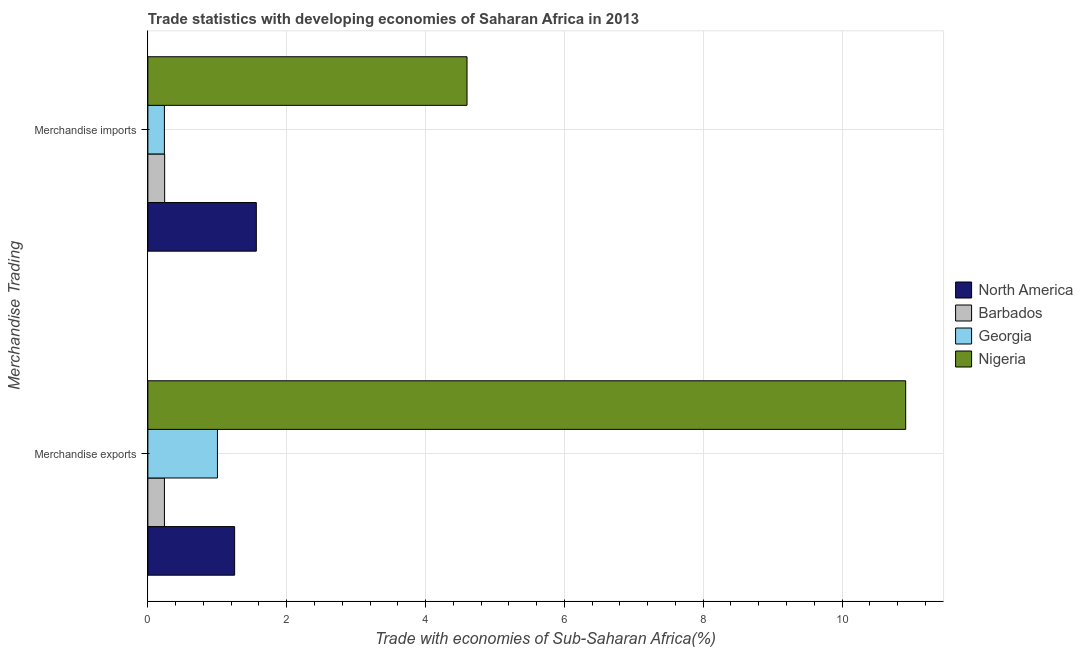How many groups of bars are there?
Provide a short and direct response. 2. How many bars are there on the 1st tick from the bottom?
Offer a very short reply. 4. What is the label of the 1st group of bars from the top?
Your answer should be very brief. Merchandise imports. What is the merchandise imports in North America?
Keep it short and to the point. 1.56. Across all countries, what is the maximum merchandise imports?
Offer a terse response. 4.6. Across all countries, what is the minimum merchandise imports?
Offer a terse response. 0.24. In which country was the merchandise imports maximum?
Your answer should be very brief. Nigeria. In which country was the merchandise imports minimum?
Your answer should be compact. Georgia. What is the total merchandise imports in the graph?
Your response must be concise. 6.64. What is the difference between the merchandise exports in Georgia and that in Barbados?
Your response must be concise. 0.76. What is the difference between the merchandise exports in Georgia and the merchandise imports in Nigeria?
Provide a short and direct response. -3.6. What is the average merchandise imports per country?
Offer a terse response. 1.66. What is the difference between the merchandise imports and merchandise exports in Nigeria?
Your response must be concise. -6.32. In how many countries, is the merchandise imports greater than 10 %?
Make the answer very short. 0. What is the ratio of the merchandise imports in Nigeria to that in Barbados?
Offer a very short reply. 19.02. Is the merchandise imports in North America less than that in Barbados?
Your response must be concise. No. In how many countries, is the merchandise imports greater than the average merchandise imports taken over all countries?
Your answer should be very brief. 1. What does the 3rd bar from the top in Merchandise imports represents?
Your answer should be compact. Barbados. What does the 2nd bar from the bottom in Merchandise imports represents?
Make the answer very short. Barbados. How many bars are there?
Your answer should be very brief. 8. Are all the bars in the graph horizontal?
Ensure brevity in your answer.  Yes. What is the difference between two consecutive major ticks on the X-axis?
Offer a terse response. 2. Are the values on the major ticks of X-axis written in scientific E-notation?
Ensure brevity in your answer.  No. Does the graph contain any zero values?
Keep it short and to the point. No. Where does the legend appear in the graph?
Offer a terse response. Center right. How are the legend labels stacked?
Offer a terse response. Vertical. What is the title of the graph?
Your answer should be very brief. Trade statistics with developing economies of Saharan Africa in 2013. What is the label or title of the X-axis?
Offer a very short reply. Trade with economies of Sub-Saharan Africa(%). What is the label or title of the Y-axis?
Keep it short and to the point. Merchandise Trading. What is the Trade with economies of Sub-Saharan Africa(%) in North America in Merchandise exports?
Give a very brief answer. 1.25. What is the Trade with economies of Sub-Saharan Africa(%) in Barbados in Merchandise exports?
Make the answer very short. 0.24. What is the Trade with economies of Sub-Saharan Africa(%) of Georgia in Merchandise exports?
Your response must be concise. 1. What is the Trade with economies of Sub-Saharan Africa(%) of Nigeria in Merchandise exports?
Offer a very short reply. 10.92. What is the Trade with economies of Sub-Saharan Africa(%) of North America in Merchandise imports?
Provide a succinct answer. 1.56. What is the Trade with economies of Sub-Saharan Africa(%) of Barbados in Merchandise imports?
Your answer should be very brief. 0.24. What is the Trade with economies of Sub-Saharan Africa(%) in Georgia in Merchandise imports?
Your answer should be very brief. 0.24. What is the Trade with economies of Sub-Saharan Africa(%) in Nigeria in Merchandise imports?
Your answer should be very brief. 4.6. Across all Merchandise Trading, what is the maximum Trade with economies of Sub-Saharan Africa(%) in North America?
Your response must be concise. 1.56. Across all Merchandise Trading, what is the maximum Trade with economies of Sub-Saharan Africa(%) in Barbados?
Your answer should be compact. 0.24. Across all Merchandise Trading, what is the maximum Trade with economies of Sub-Saharan Africa(%) in Georgia?
Give a very brief answer. 1. Across all Merchandise Trading, what is the maximum Trade with economies of Sub-Saharan Africa(%) in Nigeria?
Make the answer very short. 10.92. Across all Merchandise Trading, what is the minimum Trade with economies of Sub-Saharan Africa(%) in North America?
Your answer should be compact. 1.25. Across all Merchandise Trading, what is the minimum Trade with economies of Sub-Saharan Africa(%) in Barbados?
Provide a succinct answer. 0.24. Across all Merchandise Trading, what is the minimum Trade with economies of Sub-Saharan Africa(%) of Georgia?
Provide a short and direct response. 0.24. Across all Merchandise Trading, what is the minimum Trade with economies of Sub-Saharan Africa(%) of Nigeria?
Give a very brief answer. 4.6. What is the total Trade with economies of Sub-Saharan Africa(%) in North America in the graph?
Offer a terse response. 2.81. What is the total Trade with economies of Sub-Saharan Africa(%) in Barbados in the graph?
Make the answer very short. 0.48. What is the total Trade with economies of Sub-Saharan Africa(%) in Georgia in the graph?
Offer a terse response. 1.24. What is the total Trade with economies of Sub-Saharan Africa(%) in Nigeria in the graph?
Your response must be concise. 15.51. What is the difference between the Trade with economies of Sub-Saharan Africa(%) in North America in Merchandise exports and that in Merchandise imports?
Provide a short and direct response. -0.31. What is the difference between the Trade with economies of Sub-Saharan Africa(%) of Barbados in Merchandise exports and that in Merchandise imports?
Give a very brief answer. -0. What is the difference between the Trade with economies of Sub-Saharan Africa(%) of Georgia in Merchandise exports and that in Merchandise imports?
Offer a very short reply. 0.76. What is the difference between the Trade with economies of Sub-Saharan Africa(%) in Nigeria in Merchandise exports and that in Merchandise imports?
Provide a succinct answer. 6.32. What is the difference between the Trade with economies of Sub-Saharan Africa(%) of North America in Merchandise exports and the Trade with economies of Sub-Saharan Africa(%) of Barbados in Merchandise imports?
Give a very brief answer. 1.01. What is the difference between the Trade with economies of Sub-Saharan Africa(%) of North America in Merchandise exports and the Trade with economies of Sub-Saharan Africa(%) of Georgia in Merchandise imports?
Offer a terse response. 1.01. What is the difference between the Trade with economies of Sub-Saharan Africa(%) in North America in Merchandise exports and the Trade with economies of Sub-Saharan Africa(%) in Nigeria in Merchandise imports?
Keep it short and to the point. -3.35. What is the difference between the Trade with economies of Sub-Saharan Africa(%) in Barbados in Merchandise exports and the Trade with economies of Sub-Saharan Africa(%) in Georgia in Merchandise imports?
Offer a terse response. 0. What is the difference between the Trade with economies of Sub-Saharan Africa(%) in Barbados in Merchandise exports and the Trade with economies of Sub-Saharan Africa(%) in Nigeria in Merchandise imports?
Provide a succinct answer. -4.36. What is the difference between the Trade with economies of Sub-Saharan Africa(%) of Georgia in Merchandise exports and the Trade with economies of Sub-Saharan Africa(%) of Nigeria in Merchandise imports?
Provide a short and direct response. -3.6. What is the average Trade with economies of Sub-Saharan Africa(%) of North America per Merchandise Trading?
Keep it short and to the point. 1.41. What is the average Trade with economies of Sub-Saharan Africa(%) of Barbados per Merchandise Trading?
Provide a short and direct response. 0.24. What is the average Trade with economies of Sub-Saharan Africa(%) of Georgia per Merchandise Trading?
Ensure brevity in your answer.  0.62. What is the average Trade with economies of Sub-Saharan Africa(%) of Nigeria per Merchandise Trading?
Provide a succinct answer. 7.76. What is the difference between the Trade with economies of Sub-Saharan Africa(%) in North America and Trade with economies of Sub-Saharan Africa(%) in Barbados in Merchandise exports?
Keep it short and to the point. 1.01. What is the difference between the Trade with economies of Sub-Saharan Africa(%) in North America and Trade with economies of Sub-Saharan Africa(%) in Georgia in Merchandise exports?
Provide a short and direct response. 0.25. What is the difference between the Trade with economies of Sub-Saharan Africa(%) in North America and Trade with economies of Sub-Saharan Africa(%) in Nigeria in Merchandise exports?
Give a very brief answer. -9.67. What is the difference between the Trade with economies of Sub-Saharan Africa(%) in Barbados and Trade with economies of Sub-Saharan Africa(%) in Georgia in Merchandise exports?
Offer a very short reply. -0.76. What is the difference between the Trade with economies of Sub-Saharan Africa(%) in Barbados and Trade with economies of Sub-Saharan Africa(%) in Nigeria in Merchandise exports?
Provide a short and direct response. -10.68. What is the difference between the Trade with economies of Sub-Saharan Africa(%) of Georgia and Trade with economies of Sub-Saharan Africa(%) of Nigeria in Merchandise exports?
Provide a short and direct response. -9.91. What is the difference between the Trade with economies of Sub-Saharan Africa(%) in North America and Trade with economies of Sub-Saharan Africa(%) in Barbados in Merchandise imports?
Provide a succinct answer. 1.32. What is the difference between the Trade with economies of Sub-Saharan Africa(%) of North America and Trade with economies of Sub-Saharan Africa(%) of Georgia in Merchandise imports?
Provide a succinct answer. 1.32. What is the difference between the Trade with economies of Sub-Saharan Africa(%) in North America and Trade with economies of Sub-Saharan Africa(%) in Nigeria in Merchandise imports?
Provide a succinct answer. -3.04. What is the difference between the Trade with economies of Sub-Saharan Africa(%) in Barbados and Trade with economies of Sub-Saharan Africa(%) in Georgia in Merchandise imports?
Keep it short and to the point. 0. What is the difference between the Trade with economies of Sub-Saharan Africa(%) in Barbados and Trade with economies of Sub-Saharan Africa(%) in Nigeria in Merchandise imports?
Offer a very short reply. -4.36. What is the difference between the Trade with economies of Sub-Saharan Africa(%) of Georgia and Trade with economies of Sub-Saharan Africa(%) of Nigeria in Merchandise imports?
Offer a terse response. -4.36. What is the ratio of the Trade with economies of Sub-Saharan Africa(%) in Georgia in Merchandise exports to that in Merchandise imports?
Keep it short and to the point. 4.21. What is the ratio of the Trade with economies of Sub-Saharan Africa(%) of Nigeria in Merchandise exports to that in Merchandise imports?
Keep it short and to the point. 2.37. What is the difference between the highest and the second highest Trade with economies of Sub-Saharan Africa(%) in North America?
Offer a terse response. 0.31. What is the difference between the highest and the second highest Trade with economies of Sub-Saharan Africa(%) in Barbados?
Keep it short and to the point. 0. What is the difference between the highest and the second highest Trade with economies of Sub-Saharan Africa(%) in Georgia?
Keep it short and to the point. 0.76. What is the difference between the highest and the second highest Trade with economies of Sub-Saharan Africa(%) in Nigeria?
Your answer should be compact. 6.32. What is the difference between the highest and the lowest Trade with economies of Sub-Saharan Africa(%) in North America?
Your answer should be very brief. 0.31. What is the difference between the highest and the lowest Trade with economies of Sub-Saharan Africa(%) of Barbados?
Keep it short and to the point. 0. What is the difference between the highest and the lowest Trade with economies of Sub-Saharan Africa(%) of Georgia?
Provide a short and direct response. 0.76. What is the difference between the highest and the lowest Trade with economies of Sub-Saharan Africa(%) in Nigeria?
Your response must be concise. 6.32. 